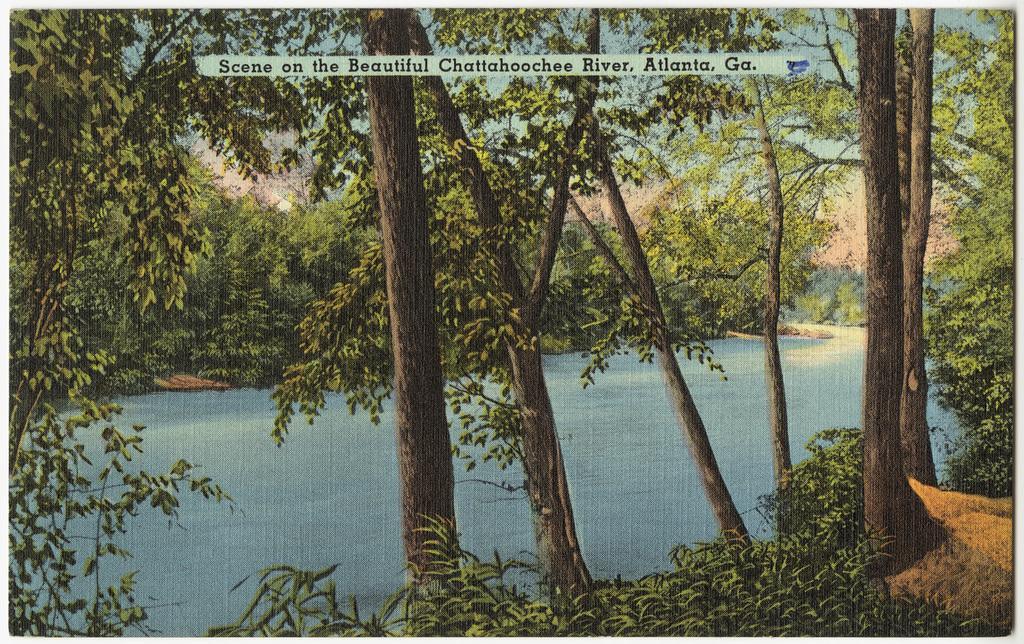Please provide a concise description of this image. This image looks like a poster. These are the trees with branches and leaves. This looks like a river with the water flowing. I think this is the quotation on the poster. 